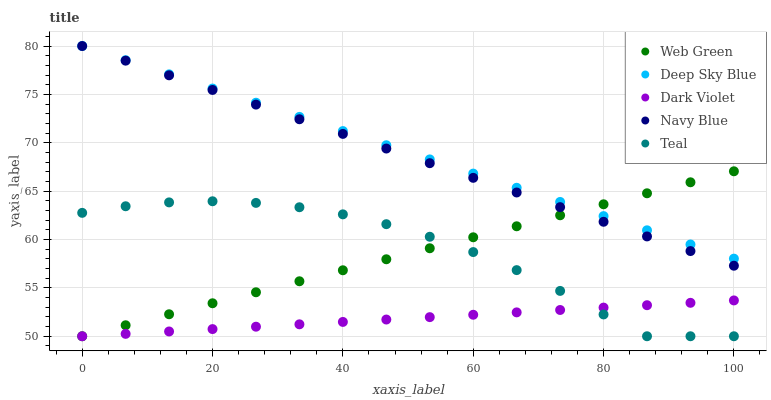Does Dark Violet have the minimum area under the curve?
Answer yes or no. Yes. Does Deep Sky Blue have the maximum area under the curve?
Answer yes or no. Yes. Does Navy Blue have the minimum area under the curve?
Answer yes or no. No. Does Navy Blue have the maximum area under the curve?
Answer yes or no. No. Is Deep Sky Blue the smoothest?
Answer yes or no. Yes. Is Teal the roughest?
Answer yes or no. Yes. Is Navy Blue the smoothest?
Answer yes or no. No. Is Navy Blue the roughest?
Answer yes or no. No. Does Teal have the lowest value?
Answer yes or no. Yes. Does Navy Blue have the lowest value?
Answer yes or no. No. Does Deep Sky Blue have the highest value?
Answer yes or no. Yes. Does Dark Violet have the highest value?
Answer yes or no. No. Is Dark Violet less than Navy Blue?
Answer yes or no. Yes. Is Deep Sky Blue greater than Dark Violet?
Answer yes or no. Yes. Does Web Green intersect Dark Violet?
Answer yes or no. Yes. Is Web Green less than Dark Violet?
Answer yes or no. No. Is Web Green greater than Dark Violet?
Answer yes or no. No. Does Dark Violet intersect Navy Blue?
Answer yes or no. No. 